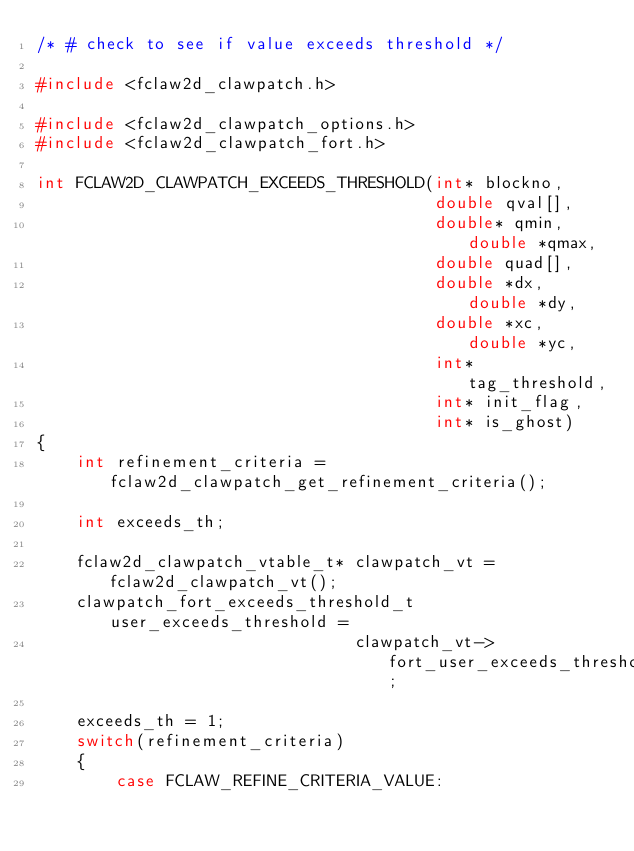<code> <loc_0><loc_0><loc_500><loc_500><_C_>/* # check to see if value exceeds threshold */

#include <fclaw2d_clawpatch.h>

#include <fclaw2d_clawpatch_options.h>
#include <fclaw2d_clawpatch_fort.h>

int FCLAW2D_CLAWPATCH_EXCEEDS_THRESHOLD(int* blockno,
                                        double qval[], 
                                        double* qmin, double *qmax,
                                        double quad[], 
                                        double *dx, double *dy, 
                                        double *xc, double *yc, 
                                        int* tag_threshold,
                                        int* init_flag,
                                        int* is_ghost)
{
    int refinement_criteria = fclaw2d_clawpatch_get_refinement_criteria();

    int exceeds_th;

    fclaw2d_clawpatch_vtable_t* clawpatch_vt = fclaw2d_clawpatch_vt();
    clawpatch_fort_exceeds_threshold_t user_exceeds_threshold = 
                                clawpatch_vt->fort_user_exceeds_threshold;

    exceeds_th = 1;
    switch(refinement_criteria)
    {
        case FCLAW_REFINE_CRITERIA_VALUE:</code> 